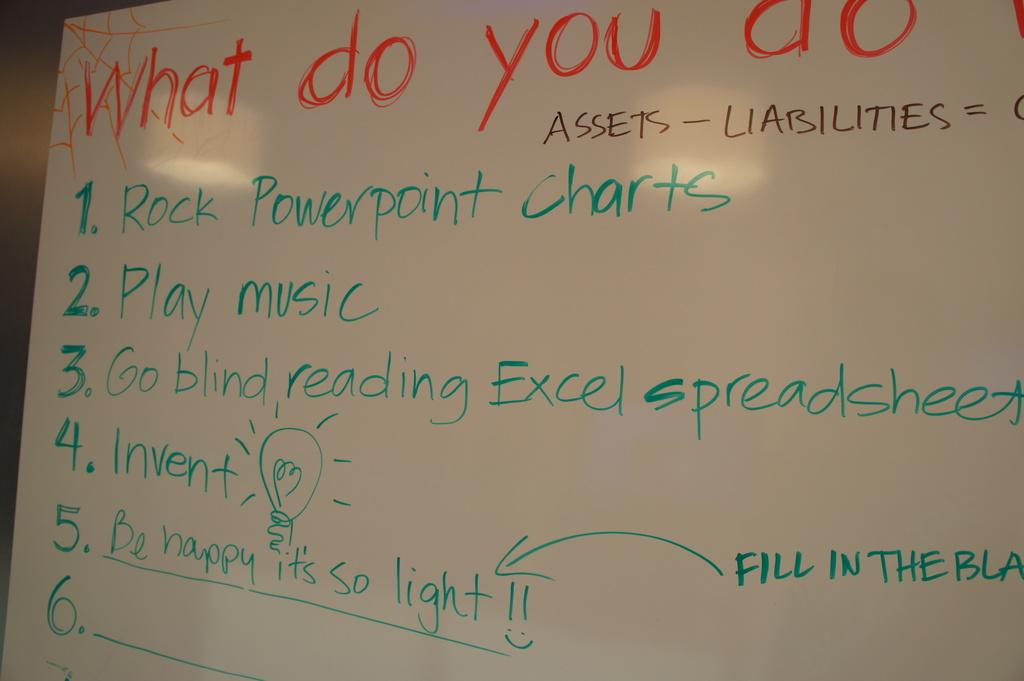<image>
Provide a brief description of the given image. The third bullet point on the board reads go blind reading Excel spreadsheets. 